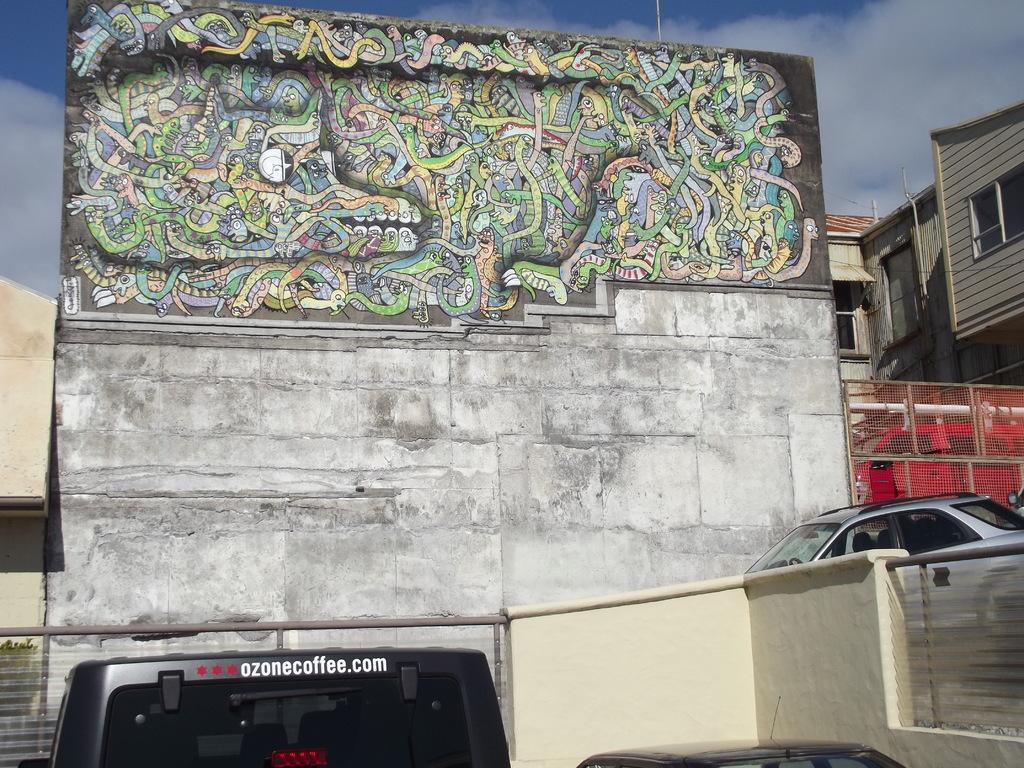How would you summarize this image in a sentence or two? In this picture we can see two cars and vehicle in the front, in the background there are some buildings, we can see painting on this wall, there is the sky and clouds at the top of the picture. 